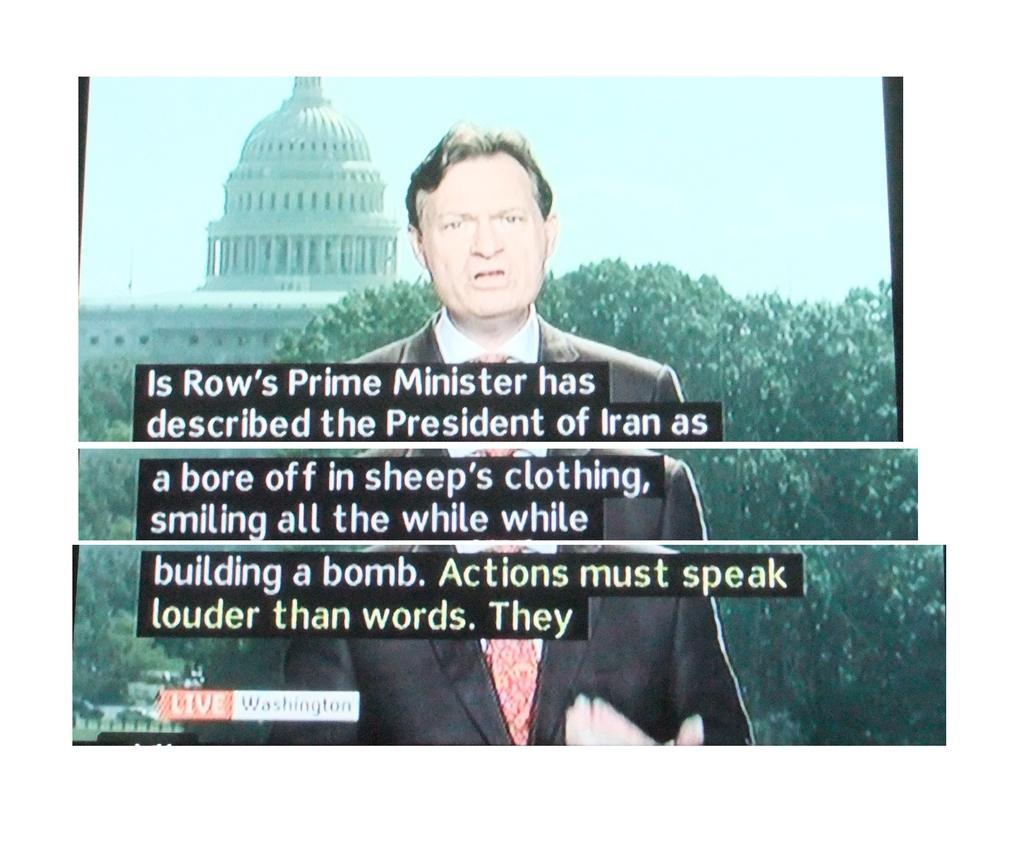Please provide a concise description of this image. In this image we can see the display screen of the news reader with papers. We can also see the text. In the background there is tree and also a monument. 